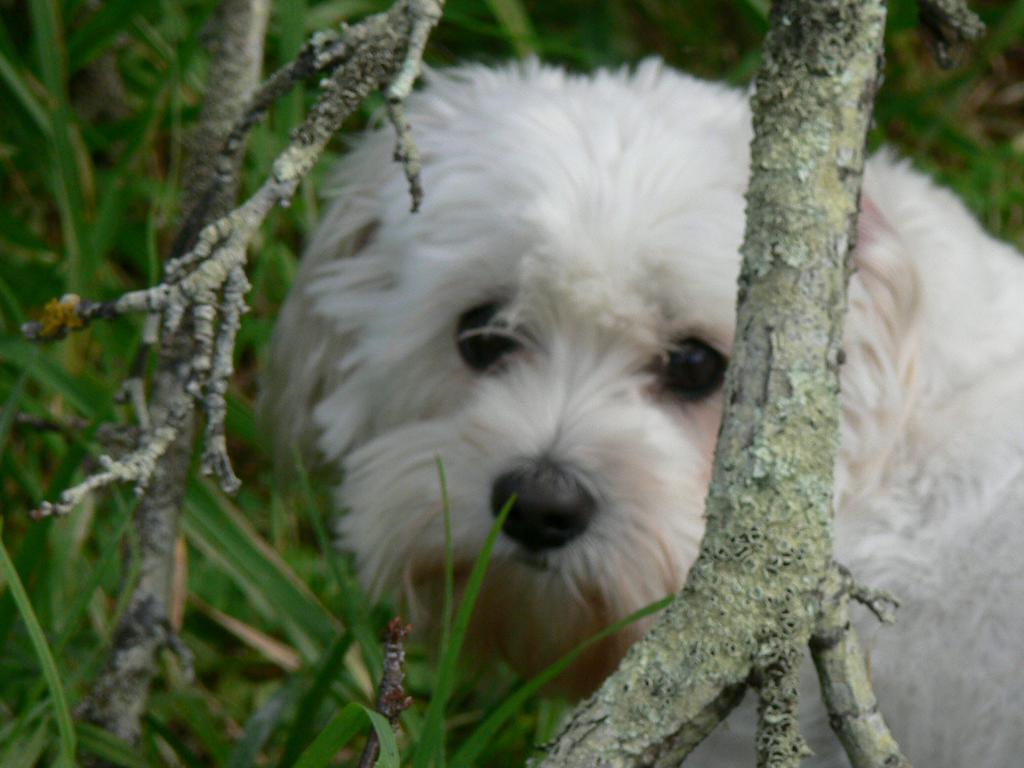How would you summarize this image in a sentence or two? In the center of the image we can see one dog, which is in white color. In front of dog, we can see wooden objects. In the background we can see the grass etc. 